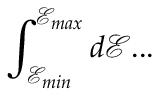<formula> <loc_0><loc_0><loc_500><loc_500>\int _ { \mathcal { E } _ { \min } } ^ { \mathcal { E } _ { \max } } d \mathcal { E } \dots</formula> 